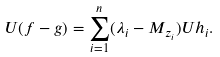<formula> <loc_0><loc_0><loc_500><loc_500>U ( f - g ) = \sum _ { i = 1 } ^ { n } ( \lambda _ { i } - M _ { z _ { i } } ) U h _ { i } .</formula> 